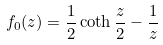<formula> <loc_0><loc_0><loc_500><loc_500>f _ { 0 } ( z ) = \frac { 1 } { 2 } \coth \frac { z } { 2 } - \frac { 1 } { z }</formula> 